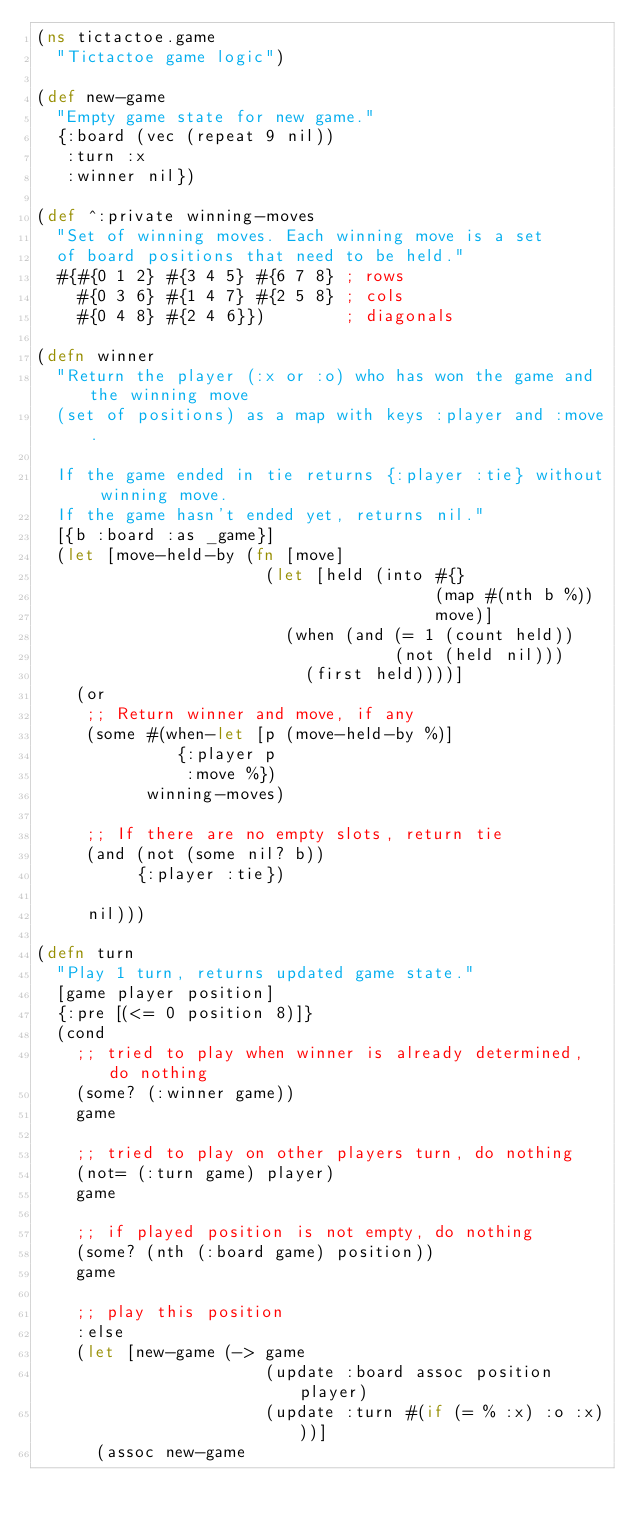<code> <loc_0><loc_0><loc_500><loc_500><_Clojure_>(ns tictactoe.game
  "Tictactoe game logic")

(def new-game
  "Empty game state for new game."
  {:board (vec (repeat 9 nil))
   :turn :x
   :winner nil})

(def ^:private winning-moves
  "Set of winning moves. Each winning move is a set
  of board positions that need to be held."
  #{#{0 1 2} #{3 4 5} #{6 7 8} ; rows
    #{0 3 6} #{1 4 7} #{2 5 8} ; cols
    #{0 4 8} #{2 4 6}})        ; diagonals

(defn winner
  "Return the player (:x or :o) who has won the game and the winning move
  (set of positions) as a map with keys :player and :move.

  If the game ended in tie returns {:player :tie} without winning move.
  If the game hasn't ended yet, returns nil."
  [{b :board :as _game}]
  (let [move-held-by (fn [move]
                       (let [held (into #{}
                                        (map #(nth b %))
                                        move)]
                         (when (and (= 1 (count held))
                                    (not (held nil)))
                           (first held))))]
    (or
     ;; Return winner and move, if any
     (some #(when-let [p (move-held-by %)]
              {:player p
               :move %})
           winning-moves)

     ;; If there are no empty slots, return tie
     (and (not (some nil? b))
          {:player :tie})

     nil)))

(defn turn
  "Play 1 turn, returns updated game state."
  [game player position]
  {:pre [(<= 0 position 8)]}
  (cond
    ;; tried to play when winner is already determined, do nothing
    (some? (:winner game))
    game

    ;; tried to play on other players turn, do nothing
    (not= (:turn game) player)
    game

    ;; if played position is not empty, do nothing
    (some? (nth (:board game) position))
    game

    ;; play this position
    :else
    (let [new-game (-> game
                       (update :board assoc position player)
                       (update :turn #(if (= % :x) :o :x)))]
      (assoc new-game</code> 